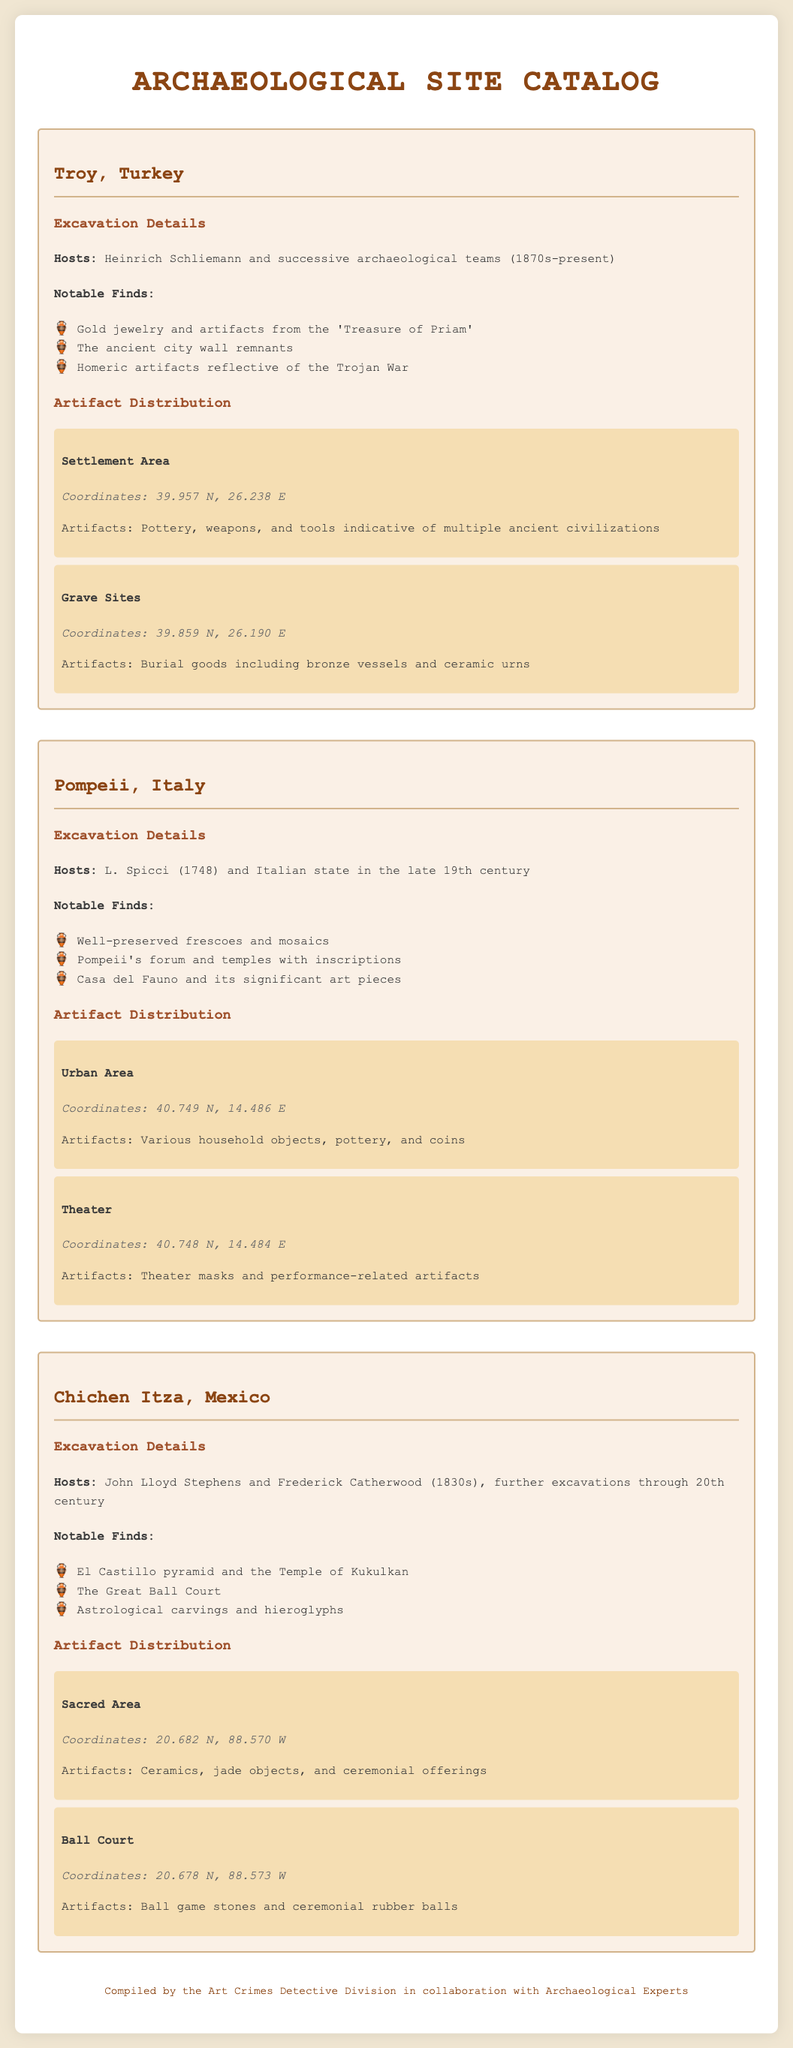What is the name of the excavation site in Turkey? The site in Turkey is referred to as "Troy."
Answer: Troy Who hosted the excavation at Pompeii? The excavation at Pompeii was hosted by L. Spicci and the Italian state.
Answer: L. Spicci and Italian state What notable find is associated with Chichen Itza? A notable find at Chichen Itza includes the El Castillo pyramid.
Answer: El Castillo pyramid What are the coordinates of the Grave Sites in Troy? The Grave Sites in Troy are located at the coordinates 39.859 N, 26.190 E.
Answer: 39.859 N, 26.190 E How many notable finds are listed for Pompeii? Three notable finds are listed for Pompeii.
Answer: Three Which region in Chichen Itza has artifacts associated with ceremonial offerings? The Sacred Area in Chichen Itza contains artifacts associated with ceremonial offerings.
Answer: Sacred Area What year did excavation at Troy begin? Excavation at Troy began in the 1870s.
Answer: 1870s What type of artifacts are found in the Urban Area of Pompeii? The Urban Area in Pompeii has various household objects, pottery, and coins.
Answer: Household objects, pottery, and coins What theme is reflected by the artifacts found in grave sites of Troy? The artifacts found in grave sites of Troy reflect burial customs.
Answer: Burial customs 